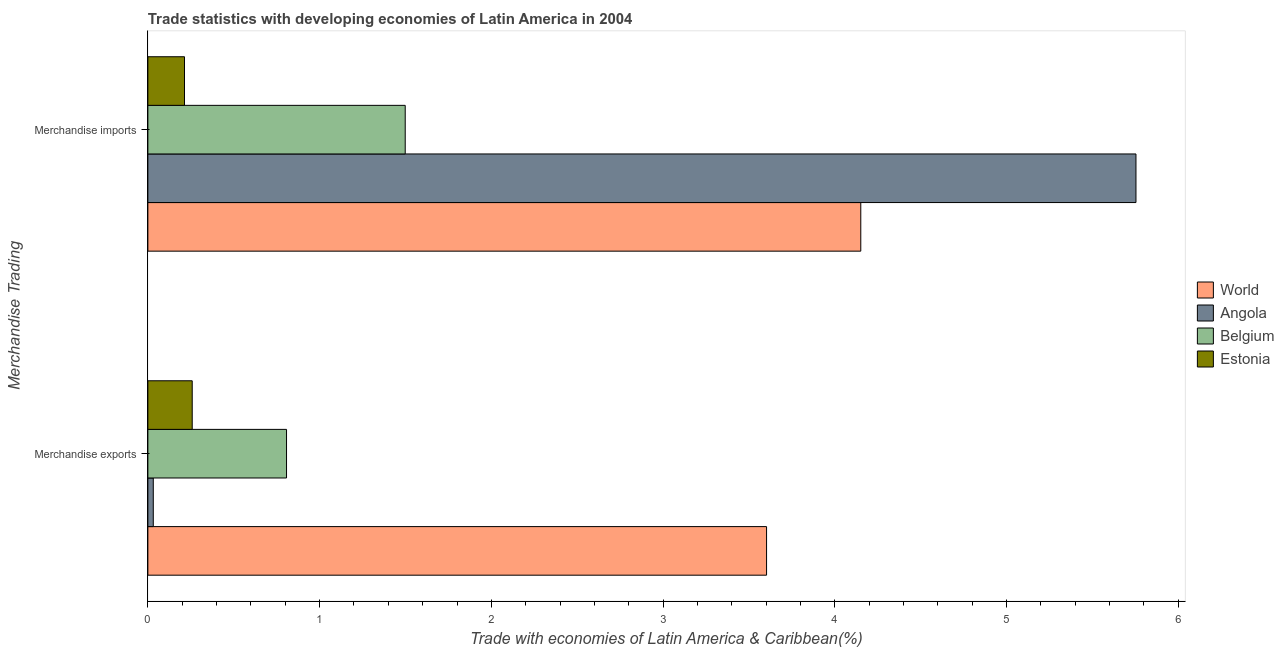Are the number of bars on each tick of the Y-axis equal?
Ensure brevity in your answer.  Yes. How many bars are there on the 2nd tick from the top?
Keep it short and to the point. 4. How many bars are there on the 1st tick from the bottom?
Your answer should be very brief. 4. What is the merchandise imports in Angola?
Make the answer very short. 5.75. Across all countries, what is the maximum merchandise imports?
Keep it short and to the point. 5.75. Across all countries, what is the minimum merchandise exports?
Keep it short and to the point. 0.03. In which country was the merchandise exports maximum?
Your response must be concise. World. In which country was the merchandise imports minimum?
Ensure brevity in your answer.  Estonia. What is the total merchandise exports in the graph?
Keep it short and to the point. 4.7. What is the difference between the merchandise exports in Angola and that in World?
Offer a very short reply. -3.57. What is the difference between the merchandise exports in Angola and the merchandise imports in Estonia?
Offer a terse response. -0.18. What is the average merchandise exports per country?
Provide a short and direct response. 1.17. What is the difference between the merchandise imports and merchandise exports in Belgium?
Ensure brevity in your answer.  0.69. In how many countries, is the merchandise imports greater than 2.4 %?
Offer a terse response. 2. What is the ratio of the merchandise imports in Belgium to that in Angola?
Provide a succinct answer. 0.26. What does the 1st bar from the top in Merchandise imports represents?
Provide a short and direct response. Estonia. What does the 1st bar from the bottom in Merchandise imports represents?
Offer a very short reply. World. How many countries are there in the graph?
Your answer should be very brief. 4. What is the difference between two consecutive major ticks on the X-axis?
Offer a very short reply. 1. Where does the legend appear in the graph?
Your response must be concise. Center right. How many legend labels are there?
Your response must be concise. 4. What is the title of the graph?
Your answer should be compact. Trade statistics with developing economies of Latin America in 2004. What is the label or title of the X-axis?
Offer a very short reply. Trade with economies of Latin America & Caribbean(%). What is the label or title of the Y-axis?
Offer a very short reply. Merchandise Trading. What is the Trade with economies of Latin America & Caribbean(%) of World in Merchandise exports?
Your response must be concise. 3.6. What is the Trade with economies of Latin America & Caribbean(%) in Angola in Merchandise exports?
Keep it short and to the point. 0.03. What is the Trade with economies of Latin America & Caribbean(%) of Belgium in Merchandise exports?
Keep it short and to the point. 0.81. What is the Trade with economies of Latin America & Caribbean(%) of Estonia in Merchandise exports?
Make the answer very short. 0.26. What is the Trade with economies of Latin America & Caribbean(%) of World in Merchandise imports?
Provide a succinct answer. 4.15. What is the Trade with economies of Latin America & Caribbean(%) of Angola in Merchandise imports?
Provide a short and direct response. 5.75. What is the Trade with economies of Latin America & Caribbean(%) of Belgium in Merchandise imports?
Give a very brief answer. 1.5. What is the Trade with economies of Latin America & Caribbean(%) of Estonia in Merchandise imports?
Your answer should be compact. 0.21. Across all Merchandise Trading, what is the maximum Trade with economies of Latin America & Caribbean(%) of World?
Your answer should be very brief. 4.15. Across all Merchandise Trading, what is the maximum Trade with economies of Latin America & Caribbean(%) of Angola?
Your response must be concise. 5.75. Across all Merchandise Trading, what is the maximum Trade with economies of Latin America & Caribbean(%) in Belgium?
Your answer should be compact. 1.5. Across all Merchandise Trading, what is the maximum Trade with economies of Latin America & Caribbean(%) of Estonia?
Your answer should be compact. 0.26. Across all Merchandise Trading, what is the minimum Trade with economies of Latin America & Caribbean(%) in World?
Your answer should be compact. 3.6. Across all Merchandise Trading, what is the minimum Trade with economies of Latin America & Caribbean(%) of Angola?
Ensure brevity in your answer.  0.03. Across all Merchandise Trading, what is the minimum Trade with economies of Latin America & Caribbean(%) of Belgium?
Keep it short and to the point. 0.81. Across all Merchandise Trading, what is the minimum Trade with economies of Latin America & Caribbean(%) of Estonia?
Offer a terse response. 0.21. What is the total Trade with economies of Latin America & Caribbean(%) of World in the graph?
Offer a very short reply. 7.75. What is the total Trade with economies of Latin America & Caribbean(%) in Angola in the graph?
Your answer should be compact. 5.79. What is the total Trade with economies of Latin America & Caribbean(%) in Belgium in the graph?
Offer a very short reply. 2.31. What is the total Trade with economies of Latin America & Caribbean(%) in Estonia in the graph?
Your answer should be very brief. 0.47. What is the difference between the Trade with economies of Latin America & Caribbean(%) in World in Merchandise exports and that in Merchandise imports?
Ensure brevity in your answer.  -0.55. What is the difference between the Trade with economies of Latin America & Caribbean(%) in Angola in Merchandise exports and that in Merchandise imports?
Your answer should be very brief. -5.72. What is the difference between the Trade with economies of Latin America & Caribbean(%) of Belgium in Merchandise exports and that in Merchandise imports?
Provide a short and direct response. -0.69. What is the difference between the Trade with economies of Latin America & Caribbean(%) of Estonia in Merchandise exports and that in Merchandise imports?
Keep it short and to the point. 0.04. What is the difference between the Trade with economies of Latin America & Caribbean(%) in World in Merchandise exports and the Trade with economies of Latin America & Caribbean(%) in Angola in Merchandise imports?
Ensure brevity in your answer.  -2.15. What is the difference between the Trade with economies of Latin America & Caribbean(%) in World in Merchandise exports and the Trade with economies of Latin America & Caribbean(%) in Belgium in Merchandise imports?
Your answer should be compact. 2.1. What is the difference between the Trade with economies of Latin America & Caribbean(%) of World in Merchandise exports and the Trade with economies of Latin America & Caribbean(%) of Estonia in Merchandise imports?
Offer a very short reply. 3.39. What is the difference between the Trade with economies of Latin America & Caribbean(%) in Angola in Merchandise exports and the Trade with economies of Latin America & Caribbean(%) in Belgium in Merchandise imports?
Your answer should be very brief. -1.47. What is the difference between the Trade with economies of Latin America & Caribbean(%) of Angola in Merchandise exports and the Trade with economies of Latin America & Caribbean(%) of Estonia in Merchandise imports?
Give a very brief answer. -0.18. What is the difference between the Trade with economies of Latin America & Caribbean(%) of Belgium in Merchandise exports and the Trade with economies of Latin America & Caribbean(%) of Estonia in Merchandise imports?
Make the answer very short. 0.59. What is the average Trade with economies of Latin America & Caribbean(%) of World per Merchandise Trading?
Keep it short and to the point. 3.88. What is the average Trade with economies of Latin America & Caribbean(%) in Angola per Merchandise Trading?
Provide a succinct answer. 2.89. What is the average Trade with economies of Latin America & Caribbean(%) of Belgium per Merchandise Trading?
Make the answer very short. 1.15. What is the average Trade with economies of Latin America & Caribbean(%) in Estonia per Merchandise Trading?
Offer a very short reply. 0.24. What is the difference between the Trade with economies of Latin America & Caribbean(%) in World and Trade with economies of Latin America & Caribbean(%) in Angola in Merchandise exports?
Your answer should be compact. 3.57. What is the difference between the Trade with economies of Latin America & Caribbean(%) in World and Trade with economies of Latin America & Caribbean(%) in Belgium in Merchandise exports?
Provide a short and direct response. 2.8. What is the difference between the Trade with economies of Latin America & Caribbean(%) in World and Trade with economies of Latin America & Caribbean(%) in Estonia in Merchandise exports?
Your answer should be compact. 3.34. What is the difference between the Trade with economies of Latin America & Caribbean(%) of Angola and Trade with economies of Latin America & Caribbean(%) of Belgium in Merchandise exports?
Offer a very short reply. -0.78. What is the difference between the Trade with economies of Latin America & Caribbean(%) of Angola and Trade with economies of Latin America & Caribbean(%) of Estonia in Merchandise exports?
Give a very brief answer. -0.23. What is the difference between the Trade with economies of Latin America & Caribbean(%) of Belgium and Trade with economies of Latin America & Caribbean(%) of Estonia in Merchandise exports?
Your response must be concise. 0.55. What is the difference between the Trade with economies of Latin America & Caribbean(%) in World and Trade with economies of Latin America & Caribbean(%) in Angola in Merchandise imports?
Offer a terse response. -1.6. What is the difference between the Trade with economies of Latin America & Caribbean(%) of World and Trade with economies of Latin America & Caribbean(%) of Belgium in Merchandise imports?
Offer a very short reply. 2.65. What is the difference between the Trade with economies of Latin America & Caribbean(%) in World and Trade with economies of Latin America & Caribbean(%) in Estonia in Merchandise imports?
Make the answer very short. 3.94. What is the difference between the Trade with economies of Latin America & Caribbean(%) of Angola and Trade with economies of Latin America & Caribbean(%) of Belgium in Merchandise imports?
Your response must be concise. 4.25. What is the difference between the Trade with economies of Latin America & Caribbean(%) in Angola and Trade with economies of Latin America & Caribbean(%) in Estonia in Merchandise imports?
Your answer should be compact. 5.54. What is the difference between the Trade with economies of Latin America & Caribbean(%) of Belgium and Trade with economies of Latin America & Caribbean(%) of Estonia in Merchandise imports?
Offer a very short reply. 1.29. What is the ratio of the Trade with economies of Latin America & Caribbean(%) of World in Merchandise exports to that in Merchandise imports?
Your answer should be compact. 0.87. What is the ratio of the Trade with economies of Latin America & Caribbean(%) in Angola in Merchandise exports to that in Merchandise imports?
Your answer should be compact. 0.01. What is the ratio of the Trade with economies of Latin America & Caribbean(%) in Belgium in Merchandise exports to that in Merchandise imports?
Your answer should be very brief. 0.54. What is the ratio of the Trade with economies of Latin America & Caribbean(%) in Estonia in Merchandise exports to that in Merchandise imports?
Provide a short and direct response. 1.21. What is the difference between the highest and the second highest Trade with economies of Latin America & Caribbean(%) in World?
Provide a succinct answer. 0.55. What is the difference between the highest and the second highest Trade with economies of Latin America & Caribbean(%) in Angola?
Offer a very short reply. 5.72. What is the difference between the highest and the second highest Trade with economies of Latin America & Caribbean(%) in Belgium?
Offer a very short reply. 0.69. What is the difference between the highest and the second highest Trade with economies of Latin America & Caribbean(%) of Estonia?
Your answer should be compact. 0.04. What is the difference between the highest and the lowest Trade with economies of Latin America & Caribbean(%) of World?
Keep it short and to the point. 0.55. What is the difference between the highest and the lowest Trade with economies of Latin America & Caribbean(%) of Angola?
Make the answer very short. 5.72. What is the difference between the highest and the lowest Trade with economies of Latin America & Caribbean(%) of Belgium?
Provide a short and direct response. 0.69. What is the difference between the highest and the lowest Trade with economies of Latin America & Caribbean(%) in Estonia?
Ensure brevity in your answer.  0.04. 